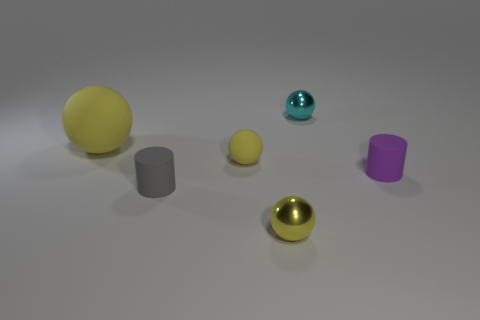The small matte object that is the same color as the large ball is what shape?
Keep it short and to the point. Sphere. The rubber object left of the small cylinder on the left side of the object behind the large yellow matte ball is what shape?
Ensure brevity in your answer.  Sphere. What number of other things are there of the same shape as the tiny yellow rubber object?
Your answer should be very brief. 3. What number of metallic things are either brown blocks or cylinders?
Make the answer very short. 0. What is the material of the sphere that is behind the yellow matte thing left of the gray matte object?
Give a very brief answer. Metal. Are there more metallic things that are behind the purple cylinder than big spheres?
Keep it short and to the point. No. Is there a big yellow cylinder made of the same material as the tiny gray object?
Make the answer very short. No. Do the tiny metallic object that is behind the small gray matte cylinder and the yellow shiny object have the same shape?
Keep it short and to the point. Yes. How many cyan balls are to the right of the small cylinder right of the tiny yellow sphere in front of the gray cylinder?
Your answer should be compact. 0. Is the number of matte objects that are in front of the gray cylinder less than the number of things right of the cyan metallic thing?
Offer a very short reply. Yes. 